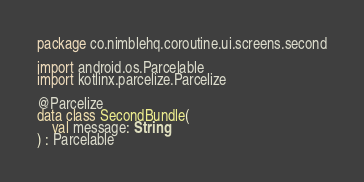Convert code to text. <code><loc_0><loc_0><loc_500><loc_500><_Kotlin_>package co.nimblehq.coroutine.ui.screens.second

import android.os.Parcelable
import kotlinx.parcelize.Parcelize

@Parcelize
data class SecondBundle(
    val message: String
) : Parcelable
</code> 